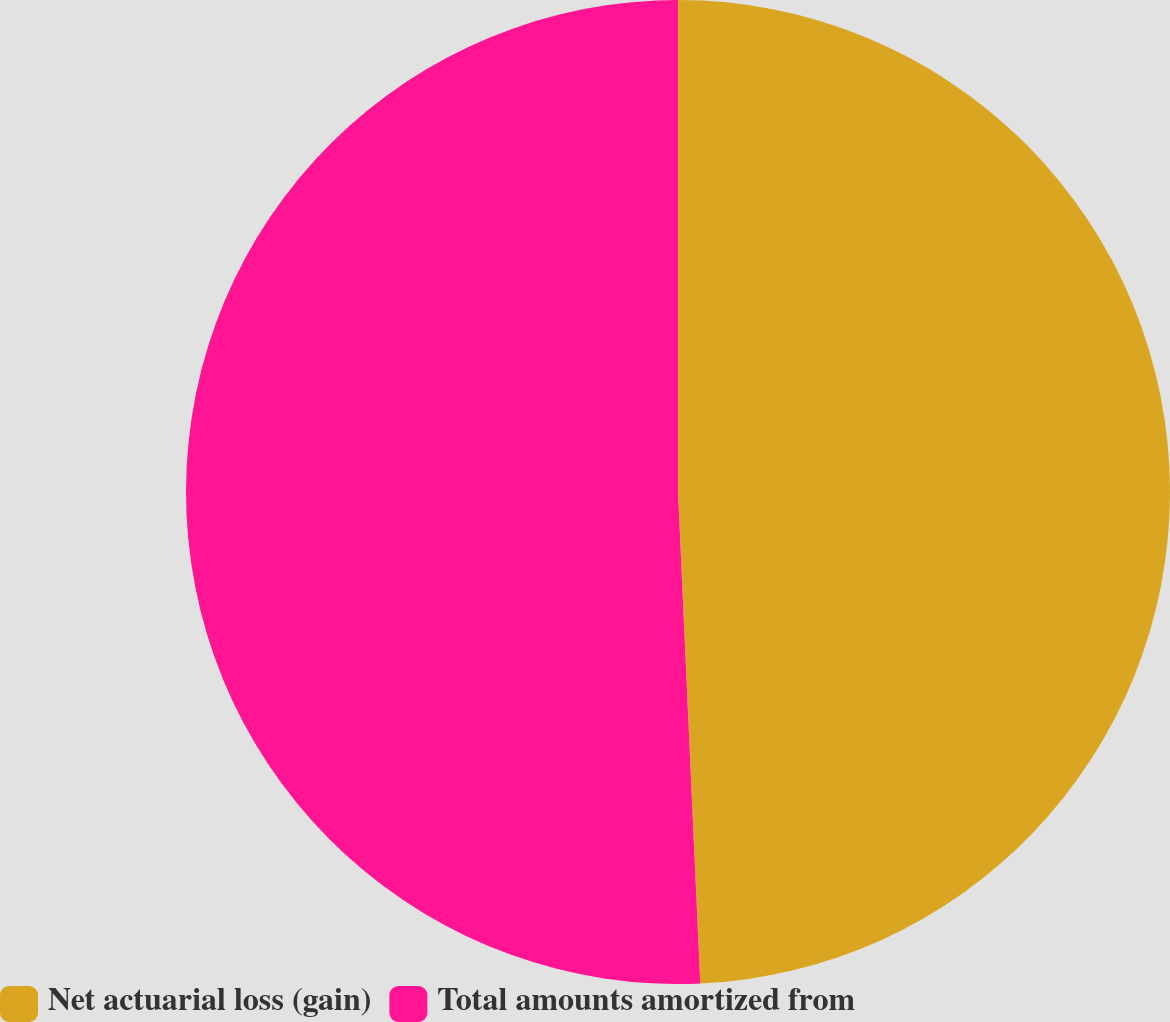Convert chart. <chart><loc_0><loc_0><loc_500><loc_500><pie_chart><fcel>Net actuarial loss (gain)<fcel>Total amounts amortized from<nl><fcel>49.28%<fcel>50.72%<nl></chart> 